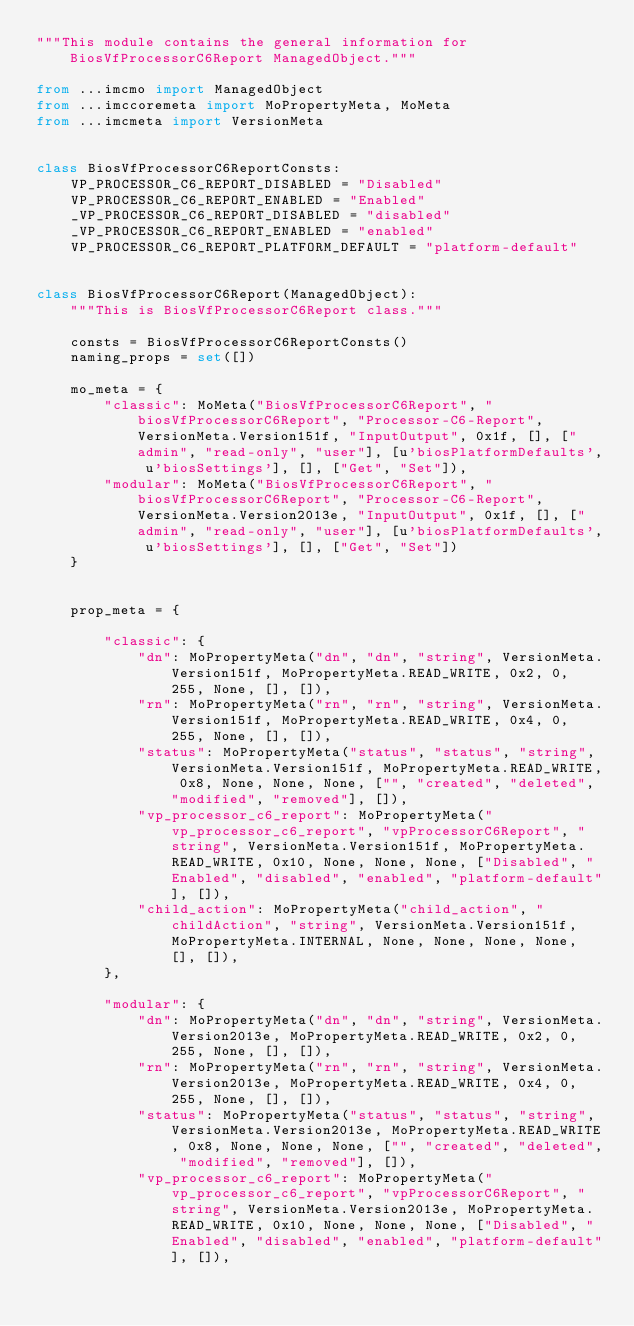<code> <loc_0><loc_0><loc_500><loc_500><_Python_>"""This module contains the general information for BiosVfProcessorC6Report ManagedObject."""

from ...imcmo import ManagedObject
from ...imccoremeta import MoPropertyMeta, MoMeta
from ...imcmeta import VersionMeta


class BiosVfProcessorC6ReportConsts:
    VP_PROCESSOR_C6_REPORT_DISABLED = "Disabled"
    VP_PROCESSOR_C6_REPORT_ENABLED = "Enabled"
    _VP_PROCESSOR_C6_REPORT_DISABLED = "disabled"
    _VP_PROCESSOR_C6_REPORT_ENABLED = "enabled"
    VP_PROCESSOR_C6_REPORT_PLATFORM_DEFAULT = "platform-default"


class BiosVfProcessorC6Report(ManagedObject):
    """This is BiosVfProcessorC6Report class."""

    consts = BiosVfProcessorC6ReportConsts()
    naming_props = set([])

    mo_meta = {
        "classic": MoMeta("BiosVfProcessorC6Report", "biosVfProcessorC6Report", "Processor-C6-Report", VersionMeta.Version151f, "InputOutput", 0x1f, [], ["admin", "read-only", "user"], [u'biosPlatformDefaults', u'biosSettings'], [], ["Get", "Set"]),
        "modular": MoMeta("BiosVfProcessorC6Report", "biosVfProcessorC6Report", "Processor-C6-Report", VersionMeta.Version2013e, "InputOutput", 0x1f, [], ["admin", "read-only", "user"], [u'biosPlatformDefaults', u'biosSettings'], [], ["Get", "Set"])
    }


    prop_meta = {

        "classic": {
            "dn": MoPropertyMeta("dn", "dn", "string", VersionMeta.Version151f, MoPropertyMeta.READ_WRITE, 0x2, 0, 255, None, [], []), 
            "rn": MoPropertyMeta("rn", "rn", "string", VersionMeta.Version151f, MoPropertyMeta.READ_WRITE, 0x4, 0, 255, None, [], []), 
            "status": MoPropertyMeta("status", "status", "string", VersionMeta.Version151f, MoPropertyMeta.READ_WRITE, 0x8, None, None, None, ["", "created", "deleted", "modified", "removed"], []), 
            "vp_processor_c6_report": MoPropertyMeta("vp_processor_c6_report", "vpProcessorC6Report", "string", VersionMeta.Version151f, MoPropertyMeta.READ_WRITE, 0x10, None, None, None, ["Disabled", "Enabled", "disabled", "enabled", "platform-default"], []), 
            "child_action": MoPropertyMeta("child_action", "childAction", "string", VersionMeta.Version151f, MoPropertyMeta.INTERNAL, None, None, None, None, [], []), 
        },

        "modular": {
            "dn": MoPropertyMeta("dn", "dn", "string", VersionMeta.Version2013e, MoPropertyMeta.READ_WRITE, 0x2, 0, 255, None, [], []), 
            "rn": MoPropertyMeta("rn", "rn", "string", VersionMeta.Version2013e, MoPropertyMeta.READ_WRITE, 0x4, 0, 255, None, [], []), 
            "status": MoPropertyMeta("status", "status", "string", VersionMeta.Version2013e, MoPropertyMeta.READ_WRITE, 0x8, None, None, None, ["", "created", "deleted", "modified", "removed"], []), 
            "vp_processor_c6_report": MoPropertyMeta("vp_processor_c6_report", "vpProcessorC6Report", "string", VersionMeta.Version2013e, MoPropertyMeta.READ_WRITE, 0x10, None, None, None, ["Disabled", "Enabled", "disabled", "enabled", "platform-default"], []), </code> 